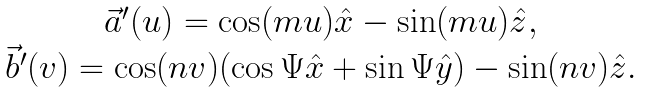Convert formula to latex. <formula><loc_0><loc_0><loc_500><loc_500>\begin{array} { c } \vec { a } ^ { \prime } ( u ) = \cos ( m u ) \hat { x } - \sin ( m u ) \hat { z } , \\ \vec { b } ^ { \prime } ( v ) = \cos ( n v ) ( \cos \Psi \hat { x } + \sin \Psi \hat { y } ) - \sin ( n v ) \hat { z } . \end{array}</formula> 